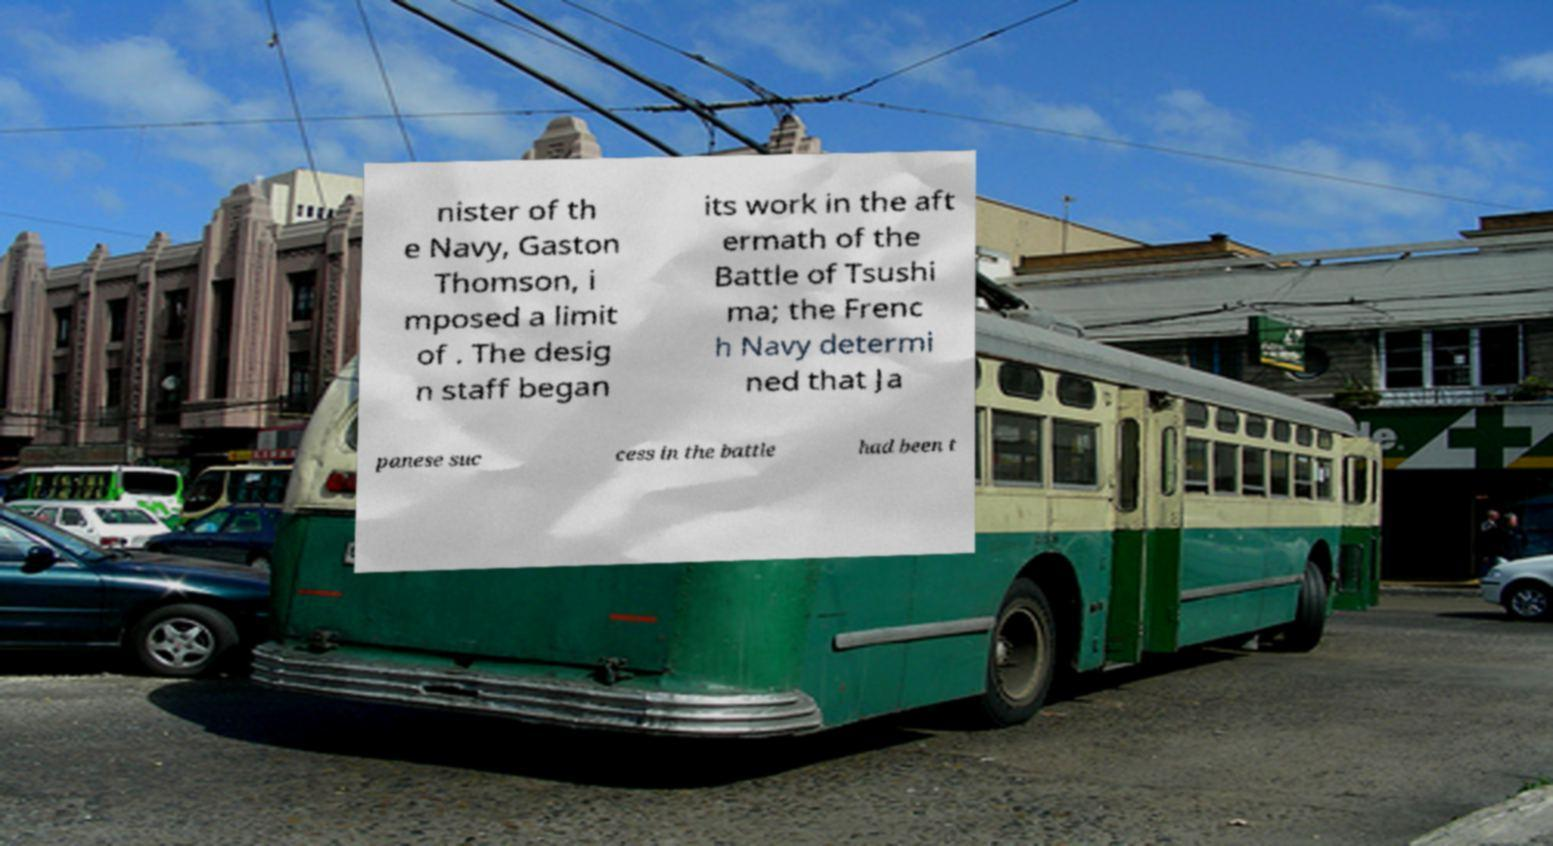There's text embedded in this image that I need extracted. Can you transcribe it verbatim? nister of th e Navy, Gaston Thomson, i mposed a limit of . The desig n staff began its work in the aft ermath of the Battle of Tsushi ma; the Frenc h Navy determi ned that Ja panese suc cess in the battle had been t 